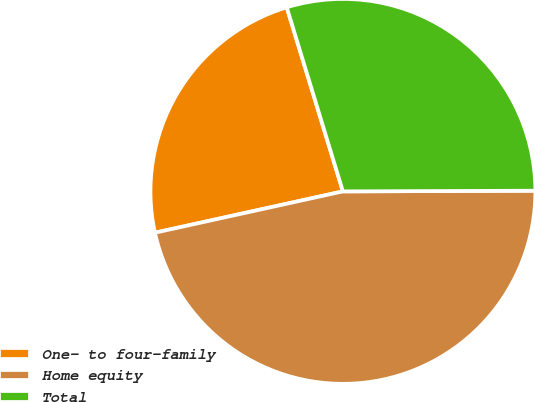Convert chart. <chart><loc_0><loc_0><loc_500><loc_500><pie_chart><fcel>One- to four-family<fcel>Home equity<fcel>Total<nl><fcel>23.73%<fcel>46.61%<fcel>29.66%<nl></chart> 